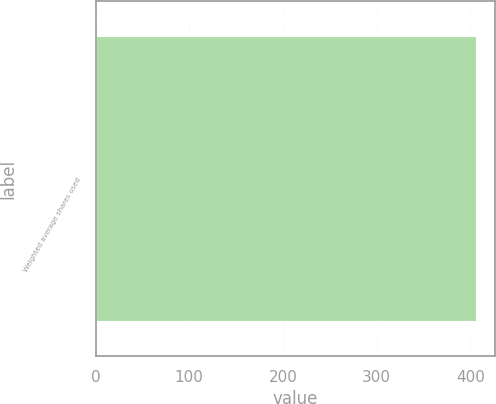Convert chart. <chart><loc_0><loc_0><loc_500><loc_500><bar_chart><fcel>Weighted average shares used<nl><fcel>406<nl></chart> 